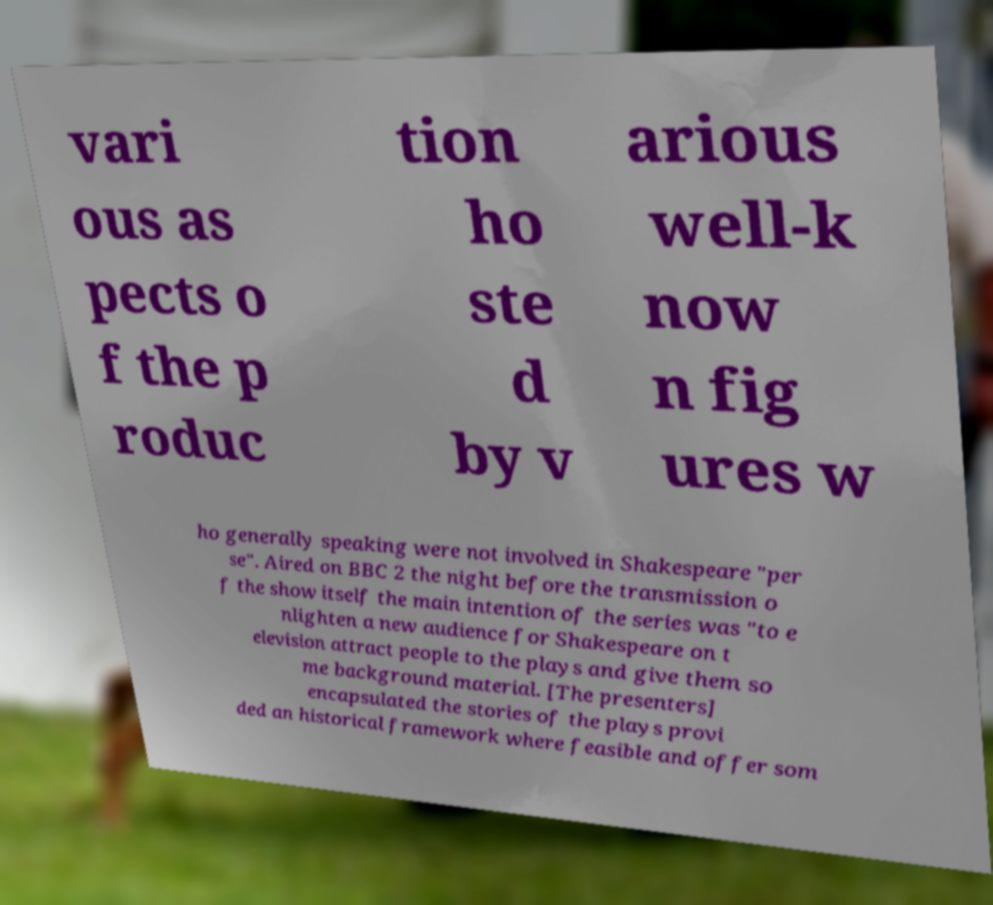Can you read and provide the text displayed in the image?This photo seems to have some interesting text. Can you extract and type it out for me? vari ous as pects o f the p roduc tion ho ste d by v arious well-k now n fig ures w ho generally speaking were not involved in Shakespeare "per se". Aired on BBC 2 the night before the transmission o f the show itself the main intention of the series was "to e nlighten a new audience for Shakespeare on t elevision attract people to the plays and give them so me background material. [The presenters] encapsulated the stories of the plays provi ded an historical framework where feasible and offer som 